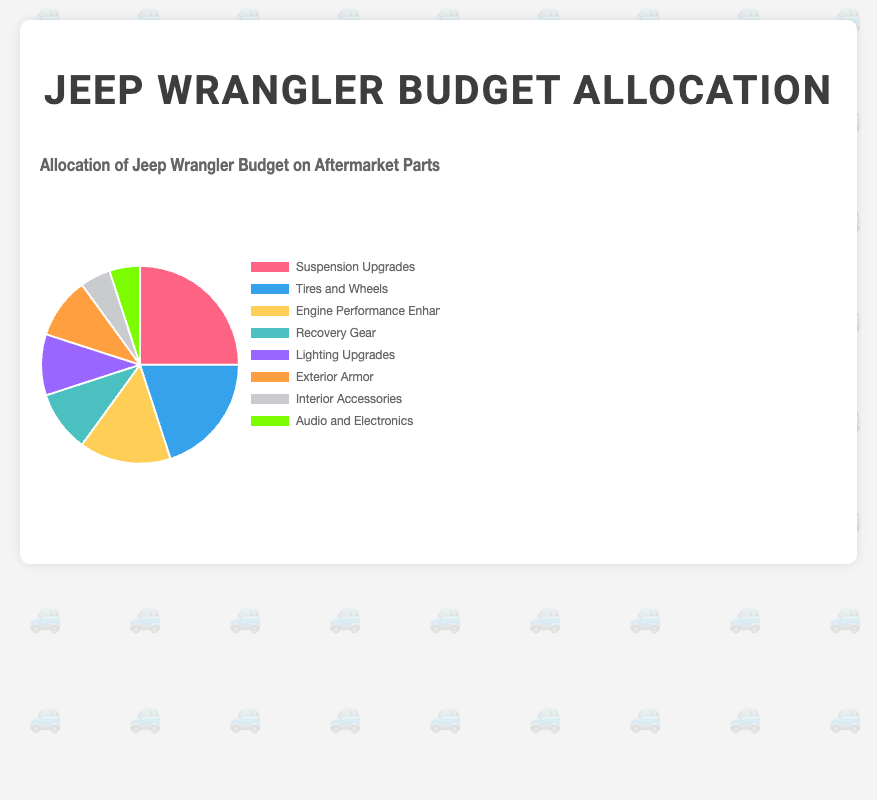What's the largest budget allocation category? The largest budget allocation category is the one with the highest percentage. Checking the data, "Suspension Upgrades" has the highest value at 25%.
Answer: Suspension Upgrades Which category has a higher budget allocation: "Tires and Wheels" or "Engine Performance Enhancements"? To find which category has a higher budget allocation, we compare the percentages. "Tires and Wheels" has 20% and "Engine Performance Enhancements" has 15%. 20% is greater than 15%.
Answer: Tires and Wheels What is the combined budget allocation for "Recovery Gear" and "Lighting Upgrades"? The budget allocation for "Recovery Gear" is 10% and for "Lighting Upgrades" is also 10%. Adding these values gives 10% + 10% = 20%.
Answer: 20% How much more is allocated to "Suspension Upgrades" compared to "Audio and Electronics"? The budget allocation for "Suspension Upgrades" is 25% and for "Audio and Electronics" is 5%. The difference is 25% - 5% = 20%.
Answer: 20% What is the total budget percentage allocated to categories with 10% each? The categories with 10% each are "Recovery Gear," "Lighting Upgrades," and "Exterior Armor." Adding these values gives 10% + 10% + 10% = 30%.
Answer: 30% Are there any categories with the same budget allocation? If so, which ones? To determine if any categories have the same budget allocation, we look for identical percentages. Both "Interior Accessories" and "Audio and Electronics" have 5%. Also, "Recovery Gear," "Lighting Upgrades," and "Exterior Armor" each have 10%.
Answer: Interior Accessories and Audio and Electronics; Recovery Gear, Lighting Upgrades, and Exterior Armor What fraction of the budget is allocated to "Interior Accessories" compared to the entire budget? The budget allocation for "Interior Accessories" is 5%. The entire budget is 100%. So, the fraction is 5/100, which simplifies to 1/20.
Answer: 1/20 What is the difference in budget allocation between "Tires and Wheels" and "Exterior Armor"? The budget allocation for "Tires and Wheels" is 20% and for "Exterior Armor" is 10%. The difference is 20% - 10% = 10%.
Answer: 10% What percentage of the budget is allocated to performance-related enhancements ("Suspension Upgrades", "Tires and Wheels", "Engine Performance Enhancements")? Summing up the allocations for "Suspension Upgrades" (25%), "Tires and Wheels" (20%), and "Engine Performance Enhancements" (15%) gives 25% + 20% + 15% = 60%.
Answer: 60% Which category is represented by the green color in the pie chart? The color green is typically associated with the last item in the provided background colors list. Matching 'green' with the color in the list, "Audio and Electronics" is green.
Answer: Audio and Electronics 